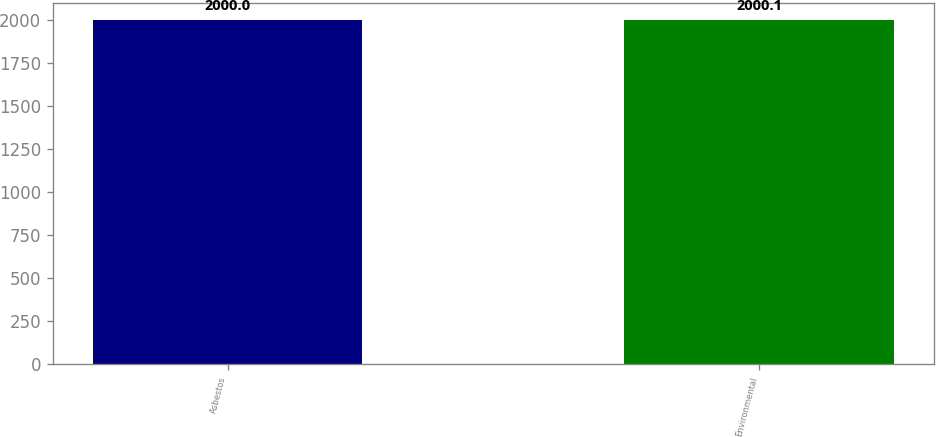<chart> <loc_0><loc_0><loc_500><loc_500><bar_chart><fcel>Asbestos<fcel>Environmental<nl><fcel>2000<fcel>2000.1<nl></chart> 